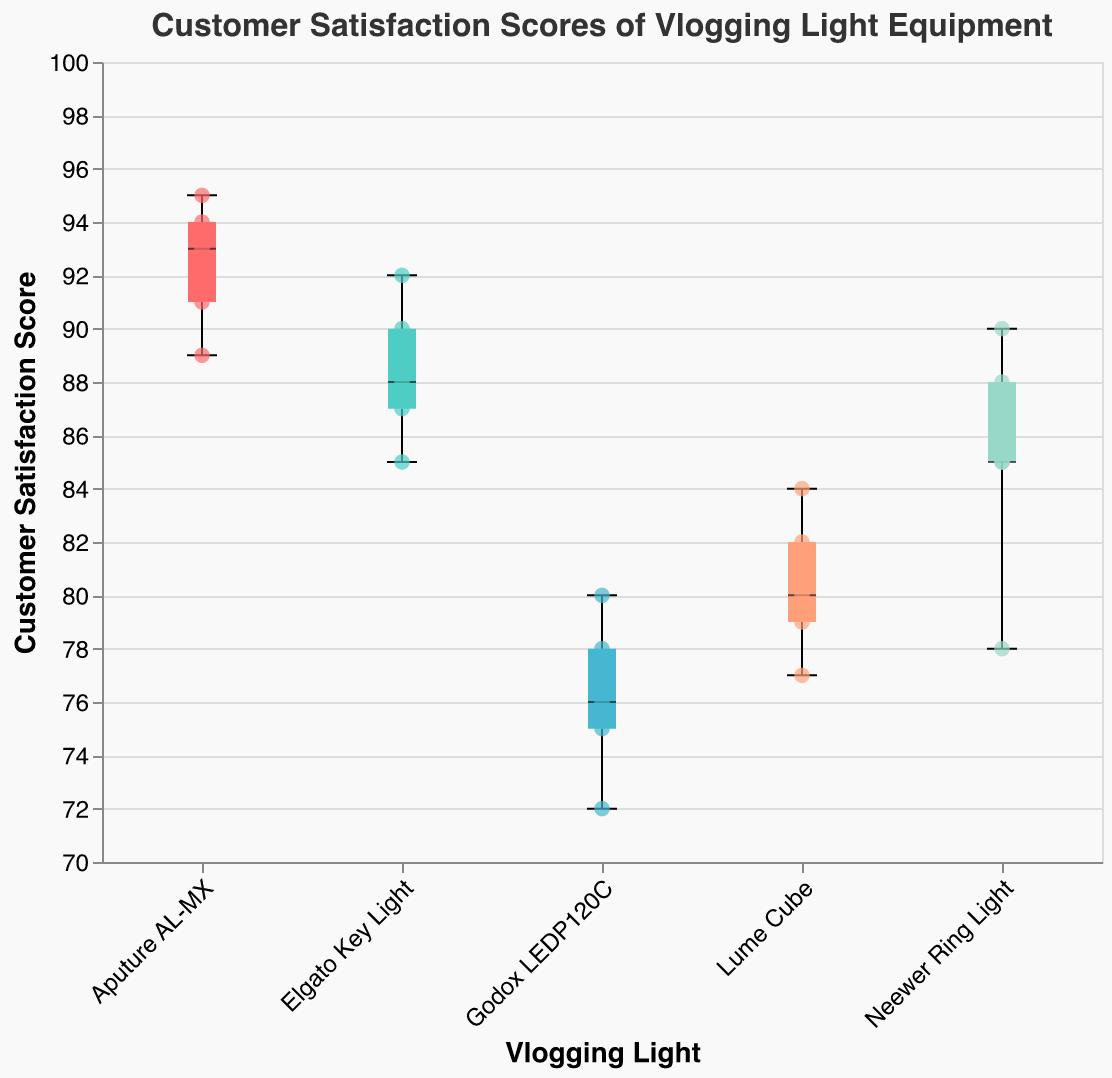What is the title of the figure? The title of the figure appears at the top and reads "Customer Satisfaction Scores of Vlogging Light Equipment".
Answer: Customer Satisfaction Scores of Vlogging Light Equipment What is the range of customer satisfaction scores for the Elgato Key Light? The range is calculated by subtracting the minimum score from the maximum score. For the Elgato Key Light, the minimum score is 85 and the maximum score is 92. The range is 92 - 85 = 7.
Answer: 7 Which vlogging light has the highest median customer satisfaction score? The highest median score comes from the box plot's central line. Observing the medians, the Aputure AL-MX has the highest median, surpassing all others.
Answer: Aputure AL-MX Between Neewer Ring Light and Lume Cube, which has a larger interquartile range (IQR)? The IQR is the difference between the third quartile (Q3) and the first quartile (Q1). For Neewer Ring Light, Q1 is around 78 and Q3 is around 88, so IQR = 88 - 78 = 10. For Lume Cube, Q1 is around 79 and Q3 is around 82.5, so IQR = 82.5 - 79 = 3.5.
Answer: Neewer Ring Light What is the median customer satisfaction score for Godox LEDP120C? The median is the central line inside the box of the box plot for Godox LEDP120C. The median score is around 76.
Answer: 76 How many data points are plotted for each vlogging light? Each scatter point on the box plot represents a data point. By counting the points, we see there are 5 for each vlogging light (Neewer Ring Light, Elgato Key Light, Lume Cube, Godox LEDP120C, and Aputure AL-MX).
Answer: 5 Which vlogging light has the smallest variability in scores? The smallest variability corresponds to the smallest range between minimum and maximum values. The Elgato Key Light has a range of 7, while others have a larger range. Therefore, Elgato Key Light has the smallest variability.
Answer: Elgato Key Light What is the highest customer satisfaction score observed, and for which product? The highest customer satisfaction score is indicated by the highest point on the plot. For this plot, the highest score is 95, which belongs to the Aputure AL-MX.
Answer: 95, Aputure AL-MX Which vlogging light has more consistent customer satisfaction scores, Neewer Ring Light or Aputure AL-MX? Consistency can be assessed by the spread of the scores. Neewer Ring Light has a wider range and IQR compared to Aputure AL-MX. Therefore, Aputure AL-MX scores are more consistent.
Answer: Aputure AL-MX What is the lower whisker value for Lume Cube? The lower whisker value is the minimum score within the plot for Lume Cube. Observing the plot, the lower whisker is at 77.
Answer: 77 